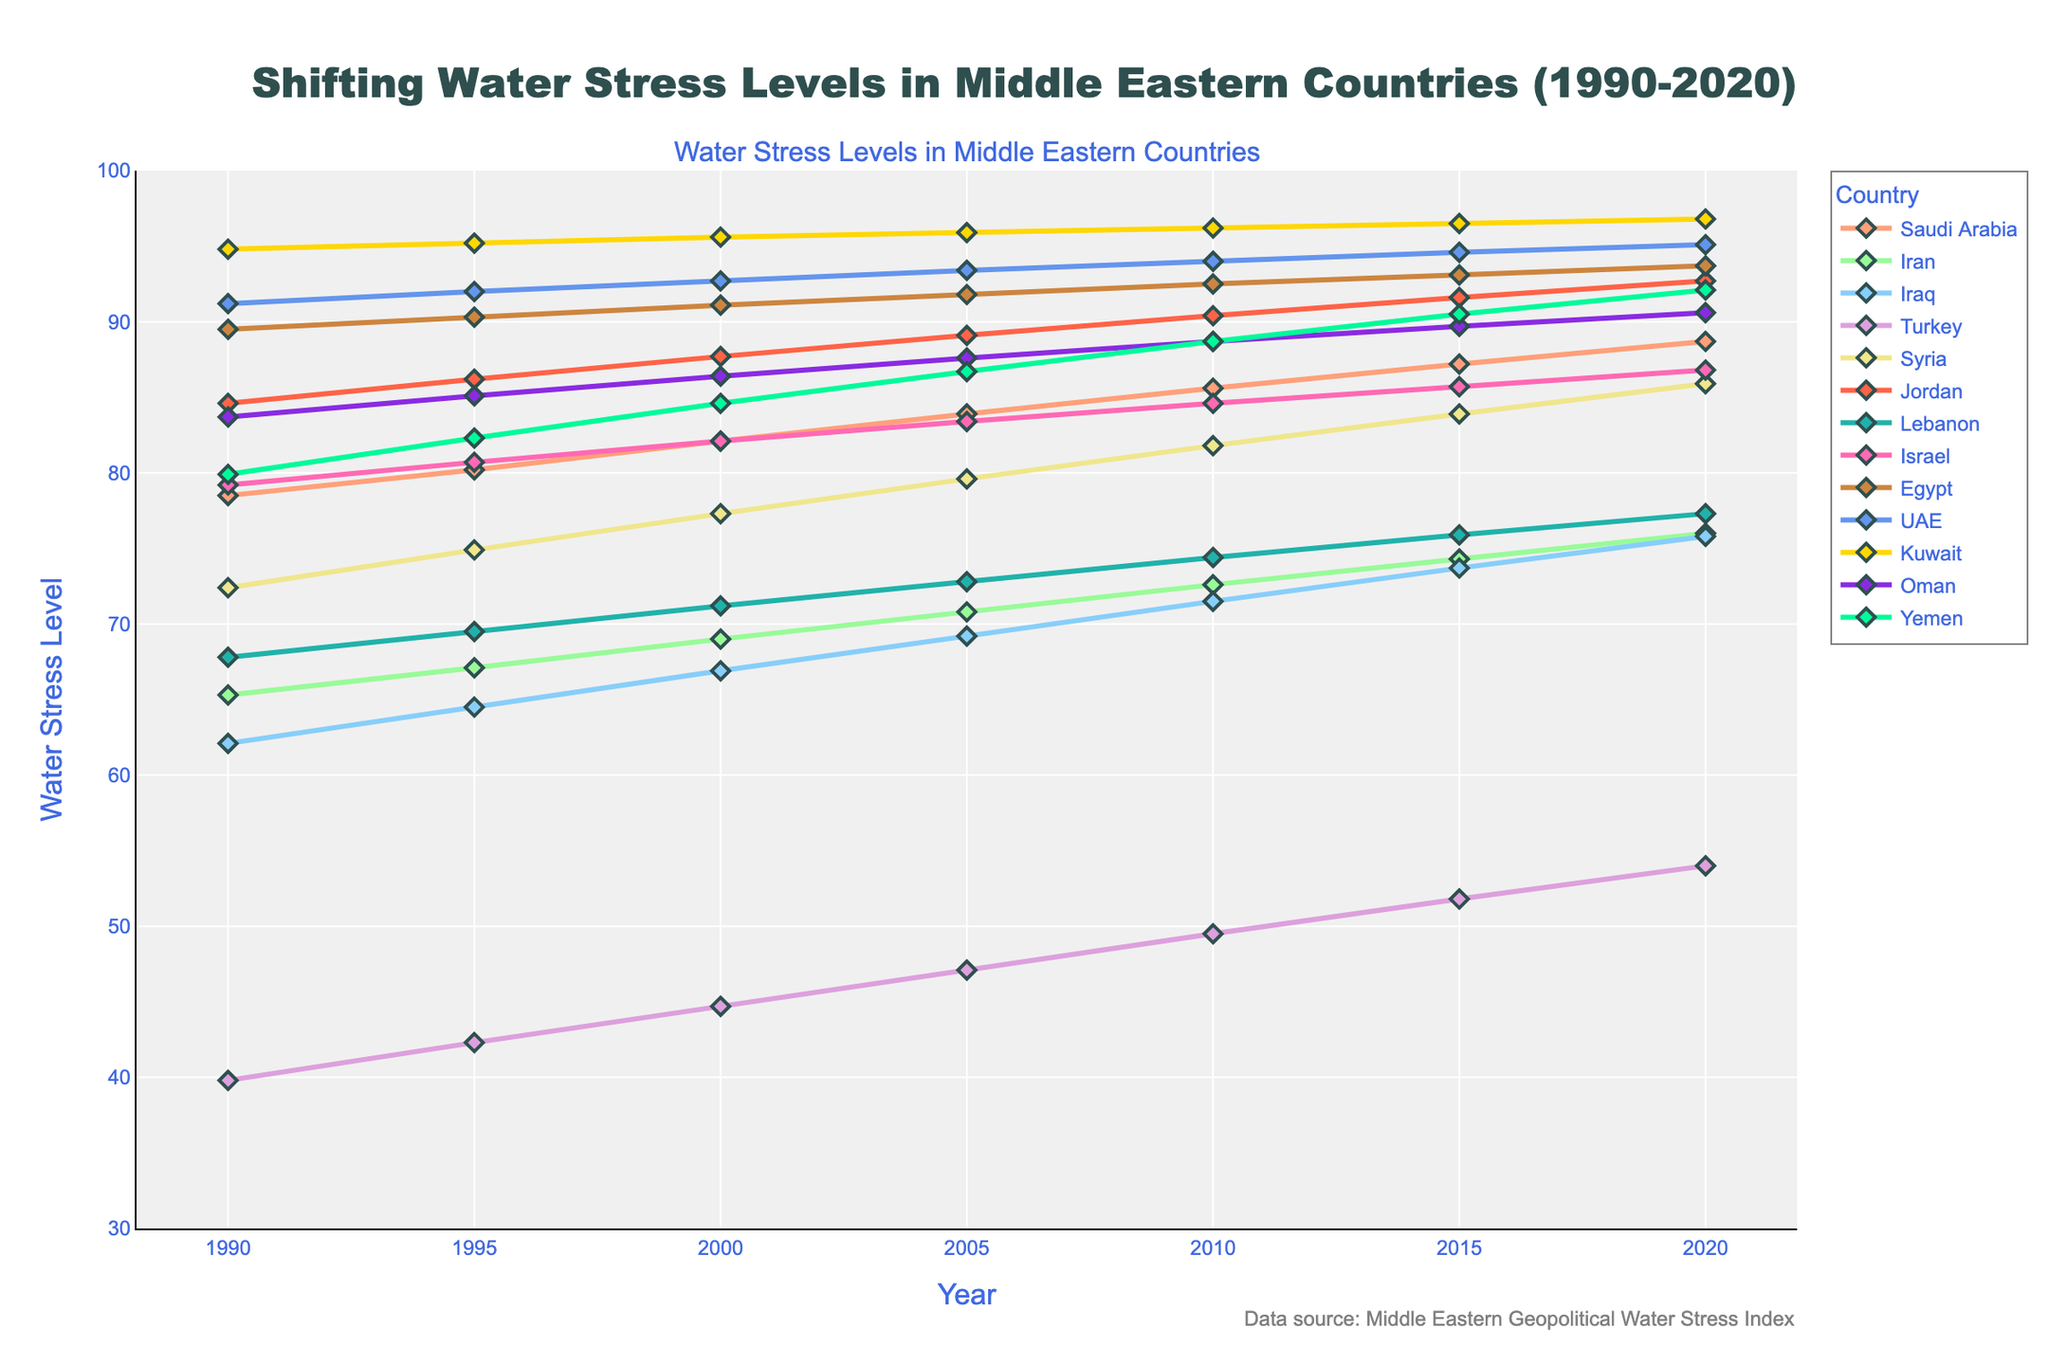What trend can be observed for water stress levels in Jordan from 1990 to 2020? Jordan's water stress levels consistently rise over the entire period. In 1990, it starts at 84.6 and reaches 92.7 by 2020, indicating a steady increase each period.
Answer: They consistently rise Which country had the highest water stress level in 2020? In 2020, the country with the highest water stress level is Kuwait, which is at 96.8 on the y-axis, the highest point among all countries listed for that year.
Answer: Kuwait How does the water stress trend in Turkey compare to that in Yemen over the years? Both Turkey and Yemen show increasing trends. However, Turkey starts much lower at 39.8 in 1990 and rises steadily to 54.0 by 2020. Yemen starts higher at 79.9 and increases to 92.1 by 2020. Thus, Turkey’s increase is sharper relative to its starting point while Yemen’s absolute increase is more modest.
Answer: Turkey's increase is sharper, but Yemen has a higher absolute increase What is the average water stress level in Iran across all available years? To find the average, sum all water stress levels for Iran (65.3 + 67.1 + 69.0 + 70.8 + 72.6 + 74.3 + 76.0) which equals 495.1, and divide by the number of years (7). Thus, 495.1 / 7 ≈ 70.7.
Answer: Approximately 70.7 Which country showed the largest increase in water stress levels from 1990 to 2020? Subtract the 1990 value from the 2020 value for each country and find the largest difference. For Kuwait, the change is 96.8 - 94.8 = 2.0. For Egypt, it's 93.7 - 89.5 = 4.2, and so on for each country. The largest change is in Jordan, with 92.7 - 84.6 = 8.1.
Answer: Jordan What is the median water stress value for the countries in 2020? List the 2020 values: 88.7, 76.0, 75.8, 54.0, 85.9, 92.7, 77.3, 86.8, 93.7, 95.1, 96.8, 90.6, 92.1. Arrange them in ascending order: 54.0, 75.8, 76.0, 77.3, 85.9, 86.8, 88.7, 90.6, 92.1, 92.7, 93.7, 95.1, 96.8. The median is the middle value, which is 88.7 (7th value).
Answer: 88.7 What is the difference in water stress levels between Oman and Saudi Arabia in 2000? In 2000, Oman has a water stress level of 86.4 and Saudi Arabia has 82.1. The difference is 86.4 - 82.1 = 4.3.
Answer: 4.3 Which country had the smallest increase in water stress levels from 1990 to 2020? Calculate the change from 1990 to 2020 for each country. The smallest change can be seen in Kuwait with 96.8 - 94.8 = 2.0.
Answer: Kuwait 